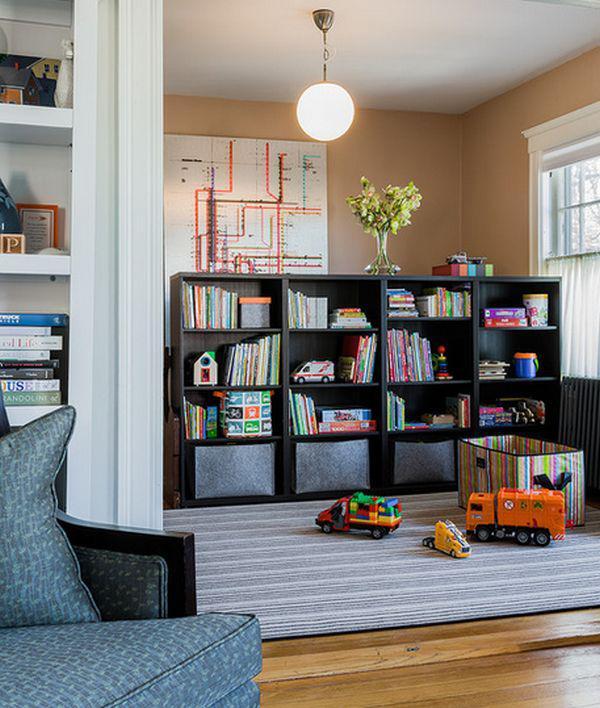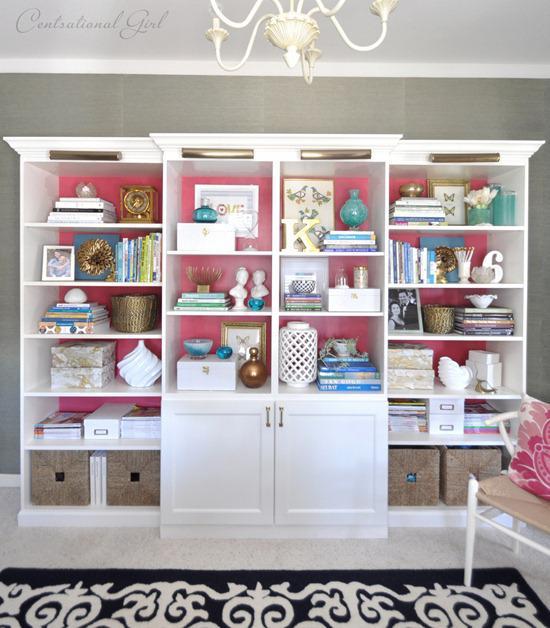The first image is the image on the left, the second image is the image on the right. Analyze the images presented: Is the assertion "There is one big white bookshelf, with pink back panels and two wicker basket on the bottle left shelf." valid? Answer yes or no. Yes. 